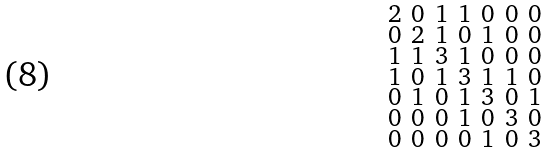<formula> <loc_0><loc_0><loc_500><loc_500>\begin{smallmatrix} 2 & 0 & 1 & 1 & 0 & 0 & 0 \\ 0 & 2 & 1 & 0 & 1 & 0 & 0 \\ 1 & 1 & 3 & 1 & 0 & 0 & 0 \\ 1 & 0 & 1 & 3 & 1 & 1 & 0 \\ 0 & 1 & 0 & 1 & 3 & 0 & 1 \\ 0 & 0 & 0 & 1 & 0 & 3 & 0 \\ 0 & 0 & 0 & 0 & 1 & 0 & 3 \end{smallmatrix}</formula> 